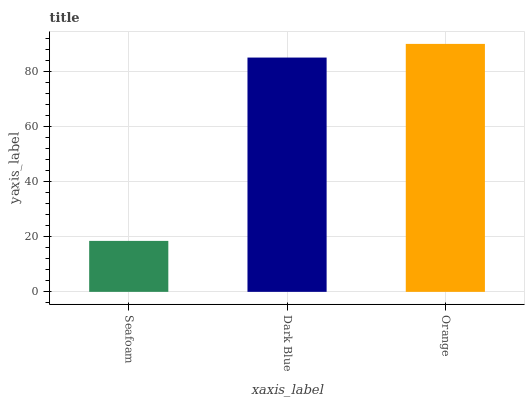Is Seafoam the minimum?
Answer yes or no. Yes. Is Orange the maximum?
Answer yes or no. Yes. Is Dark Blue the minimum?
Answer yes or no. No. Is Dark Blue the maximum?
Answer yes or no. No. Is Dark Blue greater than Seafoam?
Answer yes or no. Yes. Is Seafoam less than Dark Blue?
Answer yes or no. Yes. Is Seafoam greater than Dark Blue?
Answer yes or no. No. Is Dark Blue less than Seafoam?
Answer yes or no. No. Is Dark Blue the high median?
Answer yes or no. Yes. Is Dark Blue the low median?
Answer yes or no. Yes. Is Seafoam the high median?
Answer yes or no. No. Is Orange the low median?
Answer yes or no. No. 